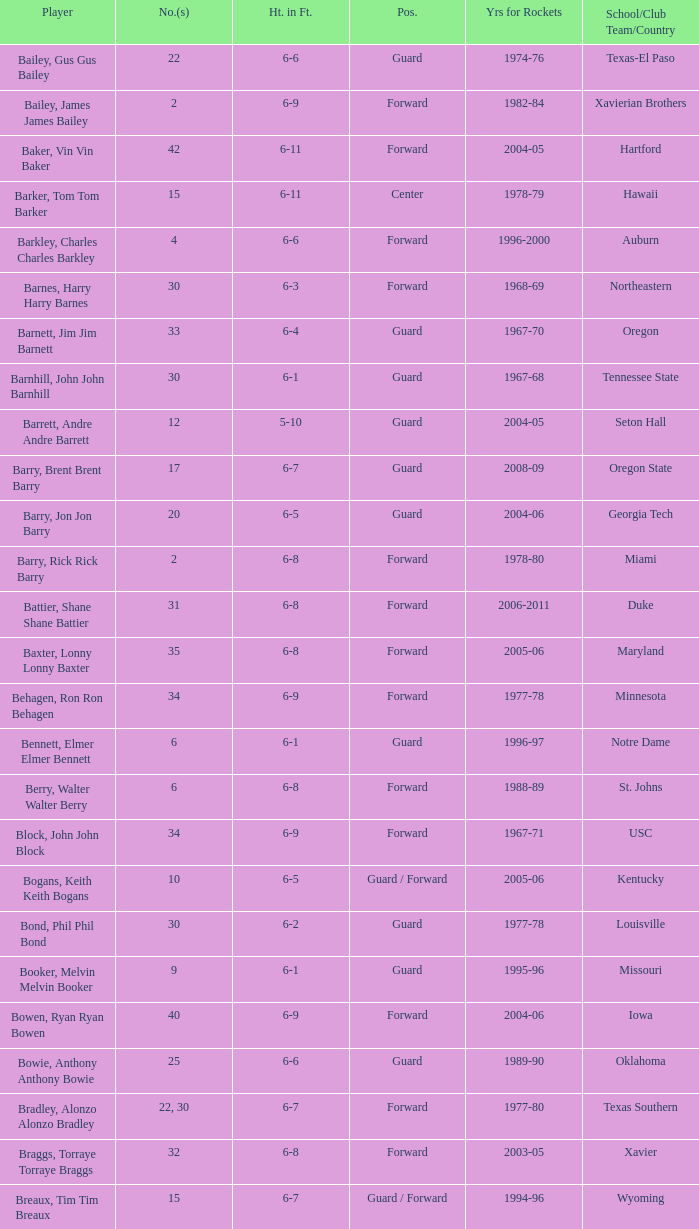What is the height of the player who attended Hartford? 6-11. 